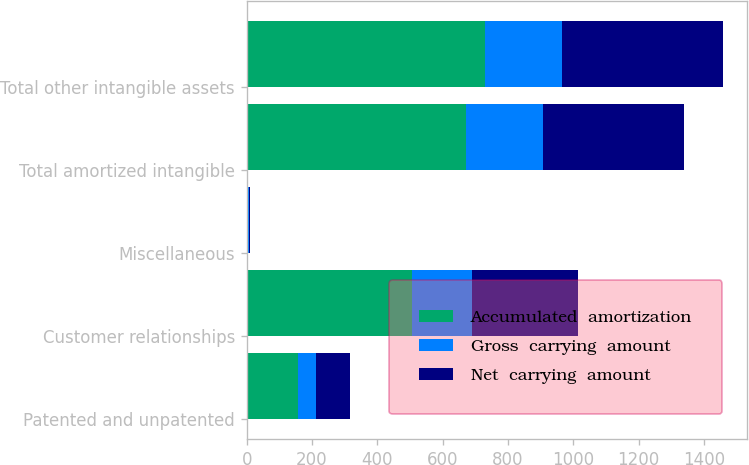<chart> <loc_0><loc_0><loc_500><loc_500><stacked_bar_chart><ecel><fcel>Patented and unpatented<fcel>Customer relationships<fcel>Miscellaneous<fcel>Total amortized intangible<fcel>Total other intangible assets<nl><fcel>Accumulated  amortization<fcel>157.7<fcel>507.6<fcel>4.9<fcel>670.2<fcel>729.8<nl><fcel>Gross  carrying  amount<fcel>52.9<fcel>181<fcel>3.2<fcel>237.1<fcel>237.1<nl><fcel>Net  carrying  amount<fcel>104.8<fcel>326.6<fcel>1.7<fcel>433.1<fcel>492.7<nl></chart> 